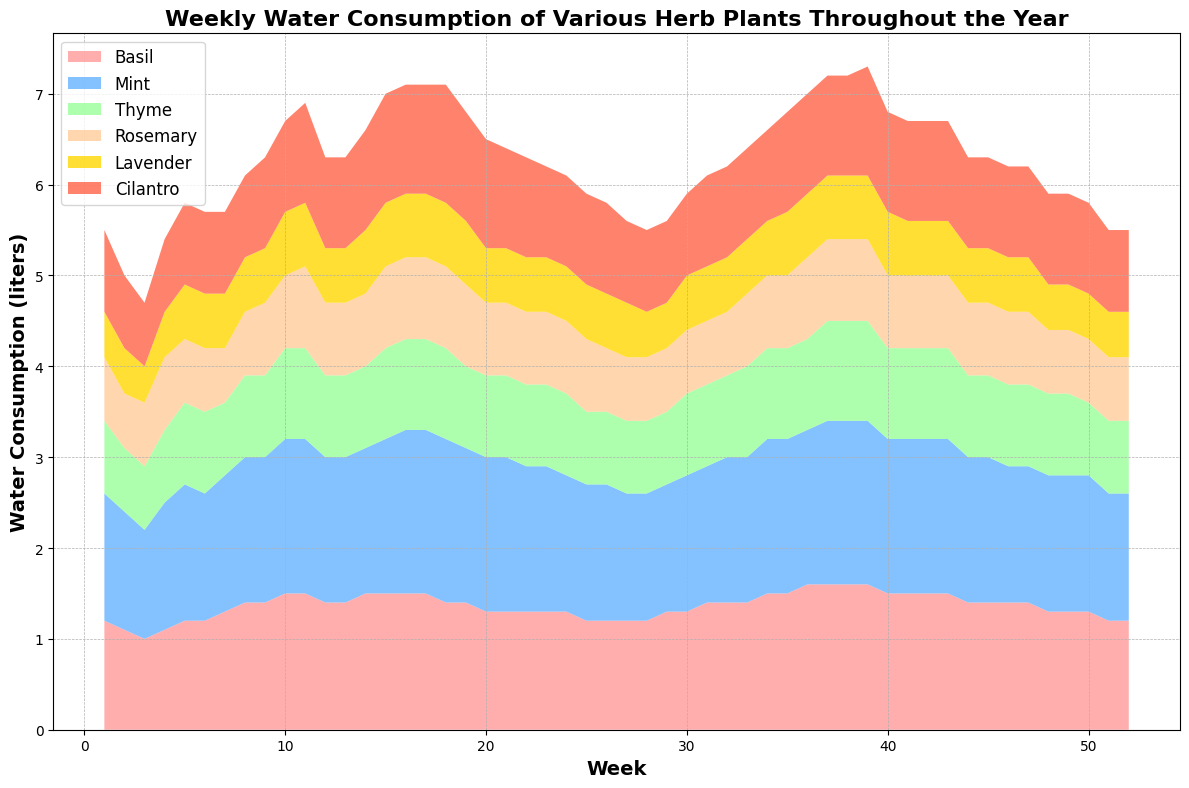How does the water consumption of Lavender in Week 1 compare to that in Week 47? Lavender's water consumption in Week 1 is 0.5 liters, and in Week 47, it is also 0.5 liters. So, there is no change in its water consumption between these weeks.
Answer: The same Which herb has the highest water consumption in Week 37? In Week 37, Basil and Mint share the highest water consumption, both at 1.6 and 1.8 liters, respectively. By looking at the stack plot, we can see these values represented higher than the other herbs.
Answer: Basil and Mint What is the difference in water consumption between Mint and Thyme in Week 20? In Week 20, Mint consumes 1.7 liters of water, and Thyme consumes 0.9 liters. The difference is calculated as 1.7 - 0.9 = 0.8 liters.
Answer: 0.8 liters Which herb's water consumption shows the most significant increase between Week 1 and Week 52? To find this, we look at the differences in water consumption for each herb from Week 1 to Week 52. Mint shows an increase from 1.4 liters in Week 1 to 1.4 liters in Week 52. There is no significant change compared to other herbs.
Answer: None Are there any weeks where the water consumption for all herbs is equal? By inspecting the chart, we need to check for weeks where all the areas are equal. There isn't any week where the consumption for all herbs is exactly the same.
Answer: No What is the average water consumption of Cilantro over the first 4 weeks? Cilantro's water consumption is 0.9, 0.8, 0.7, and 0.8 liters over the first 4 weeks. The average is calculated as (0.9 + 0.8 + 0.7 + 0.8) / 4 = 3.2 / 4 = 0.8 liters.
Answer: 0.8 liters 